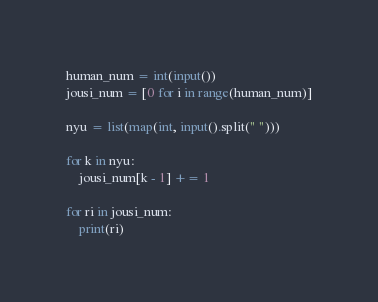Convert code to text. <code><loc_0><loc_0><loc_500><loc_500><_Python_>human_num = int(input())
jousi_num = [0 for i in range(human_num)]

nyu = list(map(int, input().split(" ")))

for k in nyu:
    jousi_num[k - 1] += 1

for ri in jousi_num:
    print(ri)
</code> 